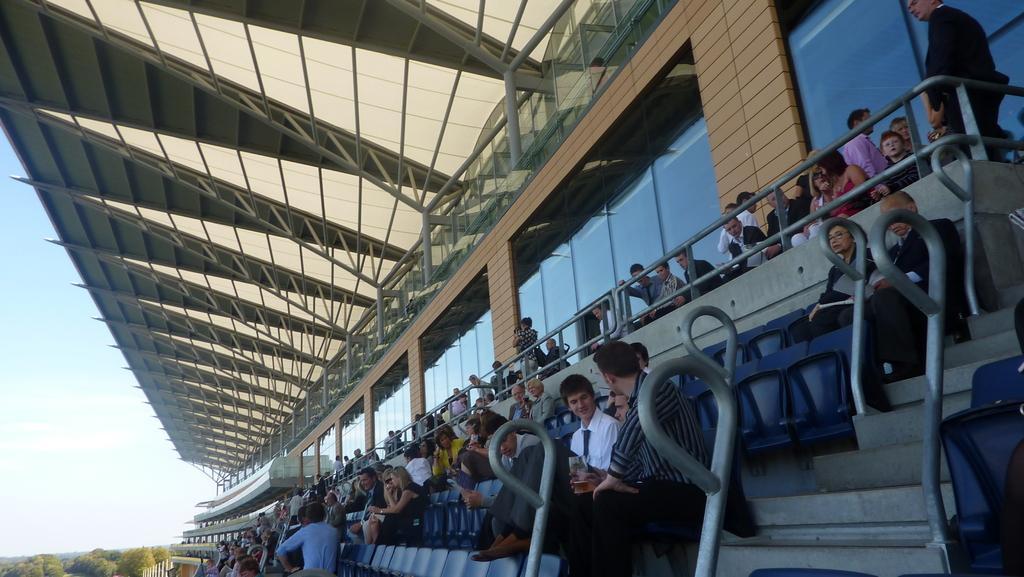Can you describe this image briefly? There are many people here sitting on the chair and few are standing. In the background we can see wall,window and a pole at the rooftop. On the left there are trees and sky. 